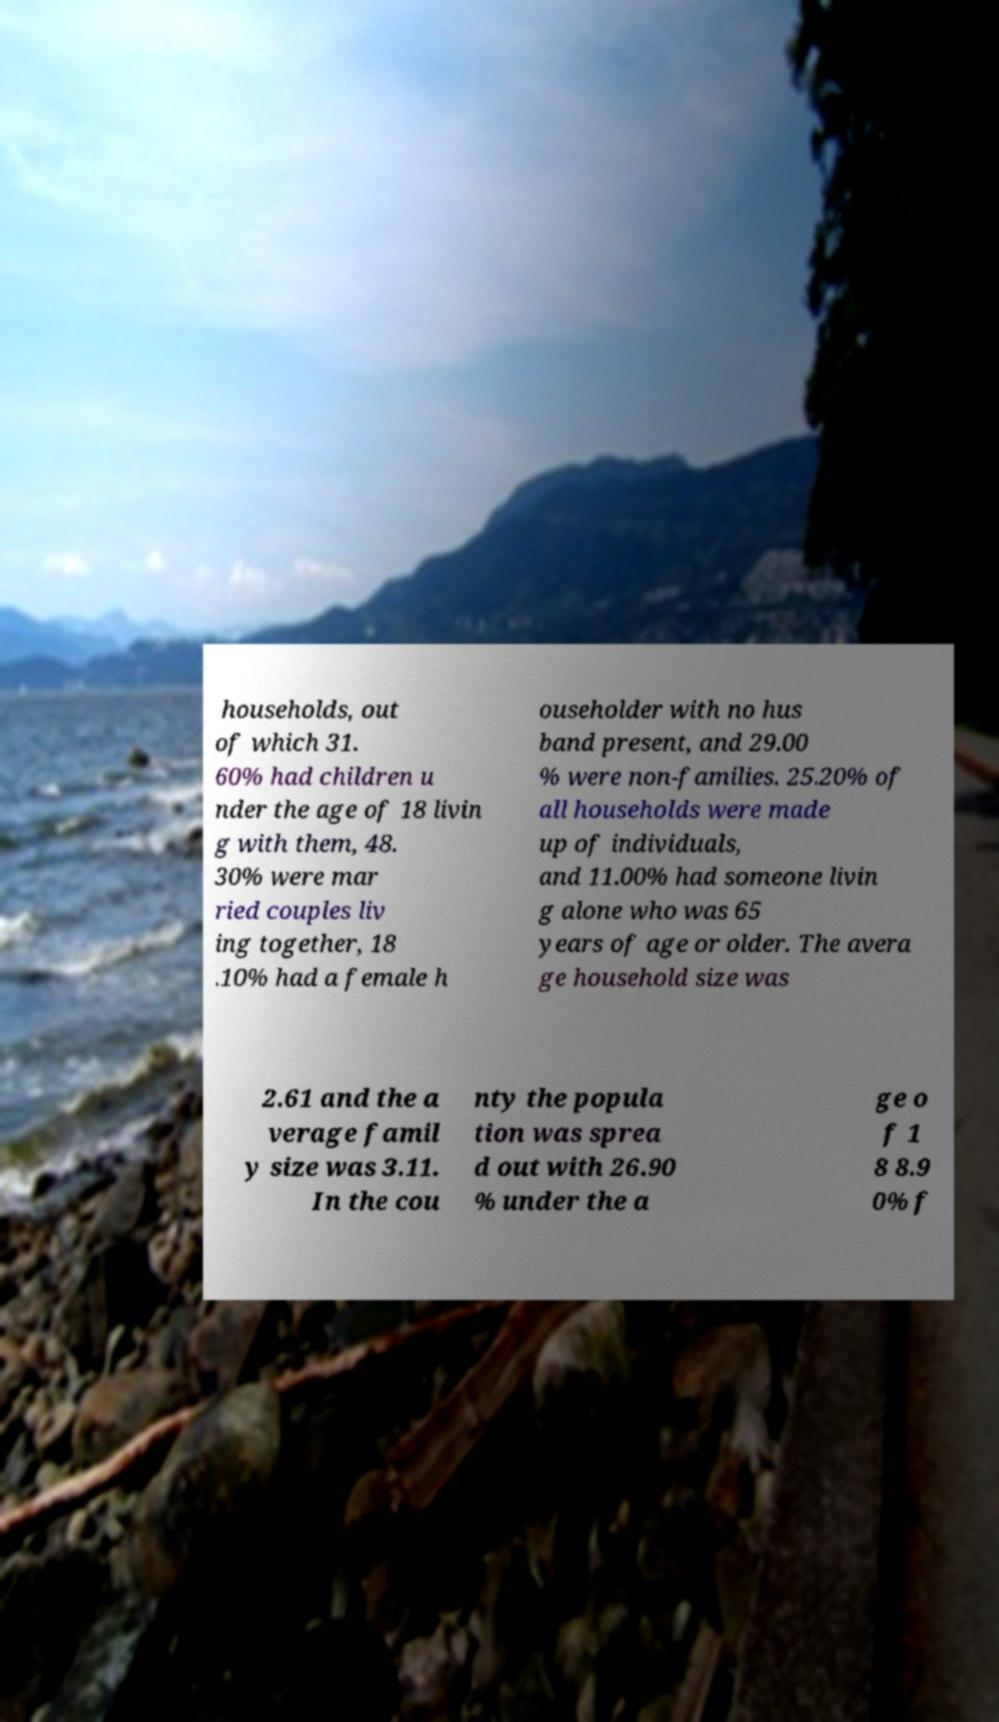There's text embedded in this image that I need extracted. Can you transcribe it verbatim? households, out of which 31. 60% had children u nder the age of 18 livin g with them, 48. 30% were mar ried couples liv ing together, 18 .10% had a female h ouseholder with no hus band present, and 29.00 % were non-families. 25.20% of all households were made up of individuals, and 11.00% had someone livin g alone who was 65 years of age or older. The avera ge household size was 2.61 and the a verage famil y size was 3.11. In the cou nty the popula tion was sprea d out with 26.90 % under the a ge o f 1 8 8.9 0% f 